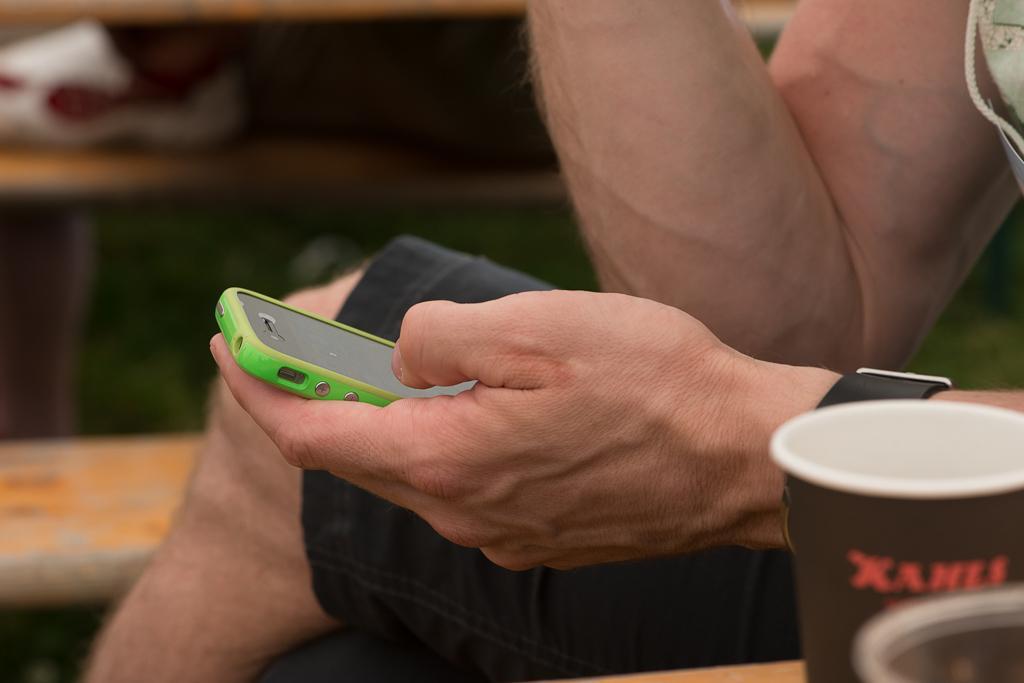Could you give a brief overview of what you see in this image? This is the picture of a person holding a mobile and the person is having a watch to the left hand. To the left side of the person there is a cup. Behind the man there is a table. 